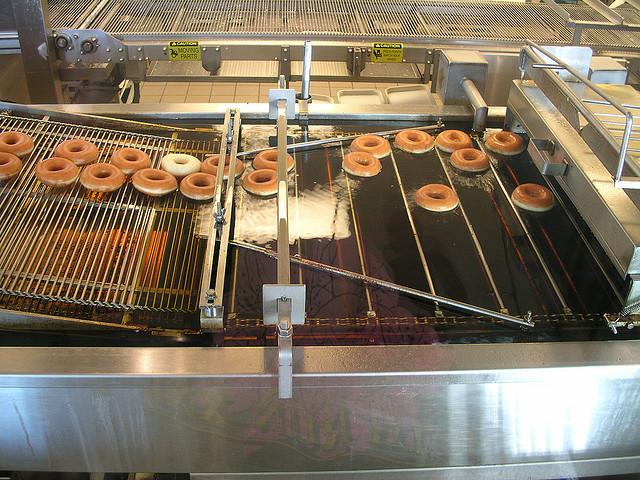What is this type of cooking called? deep fry 